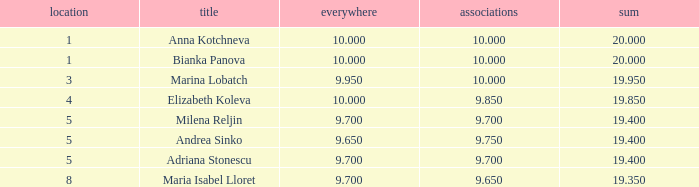How many places have bianka panova as the name, with clubs less than 10? 0.0. 